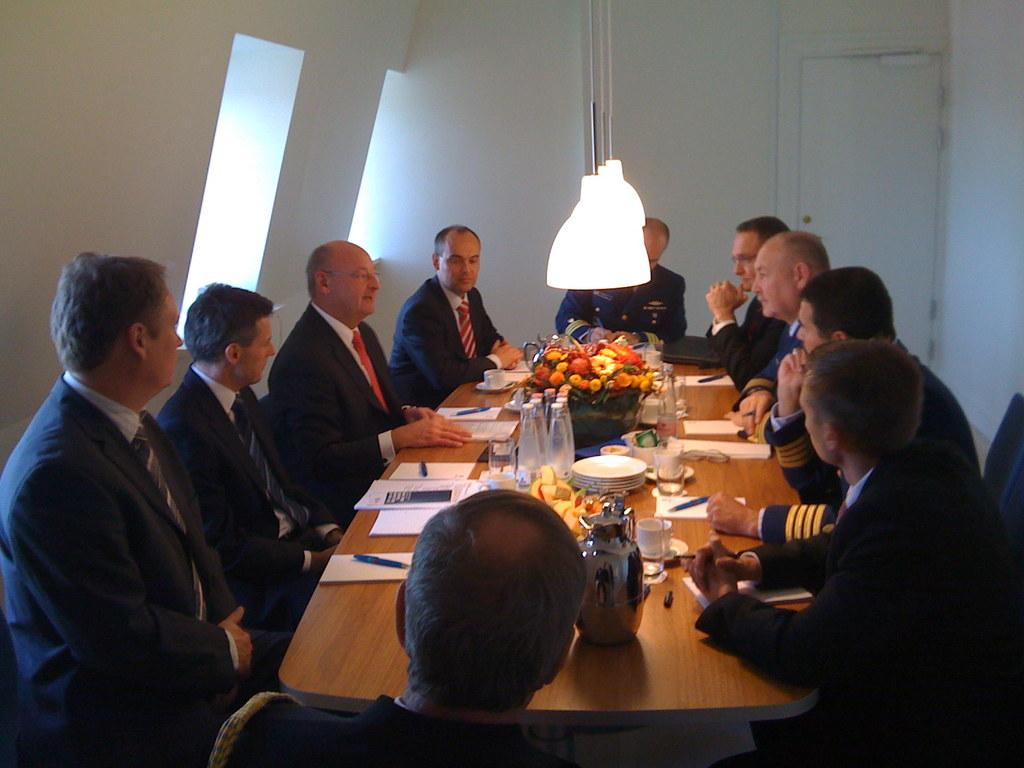What are the people in the image doing? There is a group of people sitting in the image. What can be seen on the table in the image? There are fruits, flowers, a bottle, a paper, and a pen on a table in the image. What is present in the background of the image? There is a wall in the background of the image. What is the source of light in the image? There is a light at the top of the image. What type of business is being discussed in the image? There is no indication of a business discussion in the image; it simply shows a group of people sitting and a table with various objects. What kind of insurance policy is being reviewed in the image? There is no mention of insurance or any related documents in the image. How many bananas are visible on the table in the image? There is no banana present on the table in the image. 